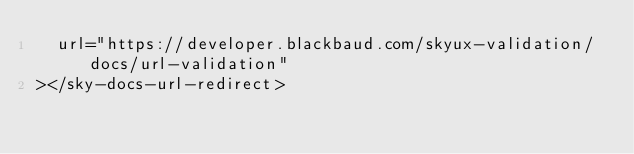Convert code to text. <code><loc_0><loc_0><loc_500><loc_500><_HTML_>  url="https://developer.blackbaud.com/skyux-validation/docs/url-validation"
></sky-docs-url-redirect>
</code> 